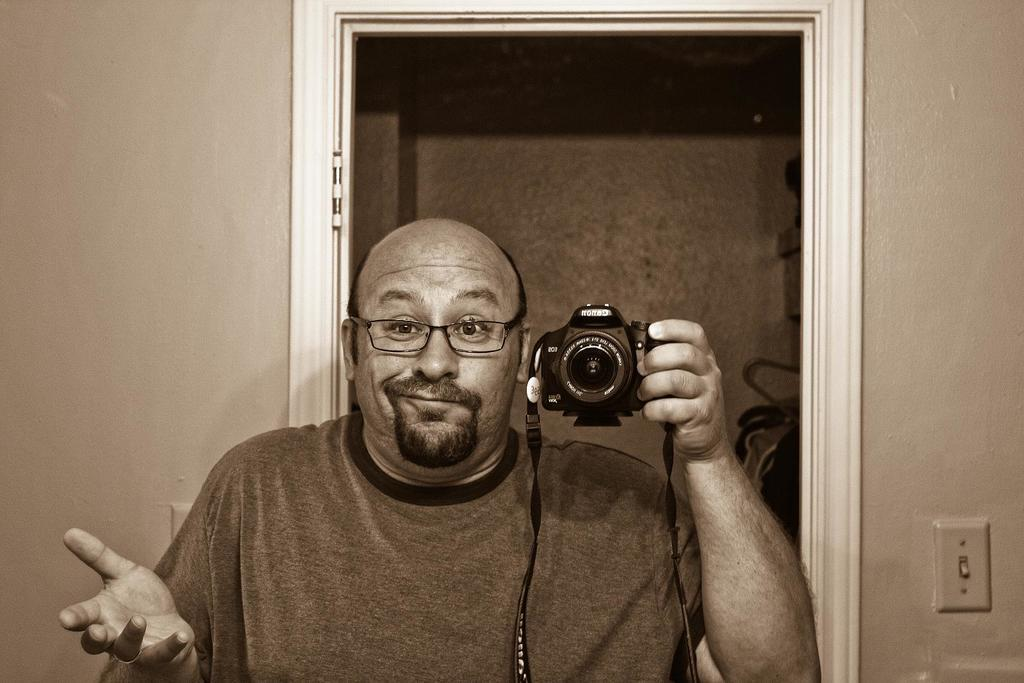What is happening in the image? There is a person in the image who is taking a picture of himself. What is the person holding in his hand? The person is holding a camera in his hand. What type of gold object is visible in the image? There is no gold object present in the image. Is there a desk in the image? There is no desk visible in the image. 